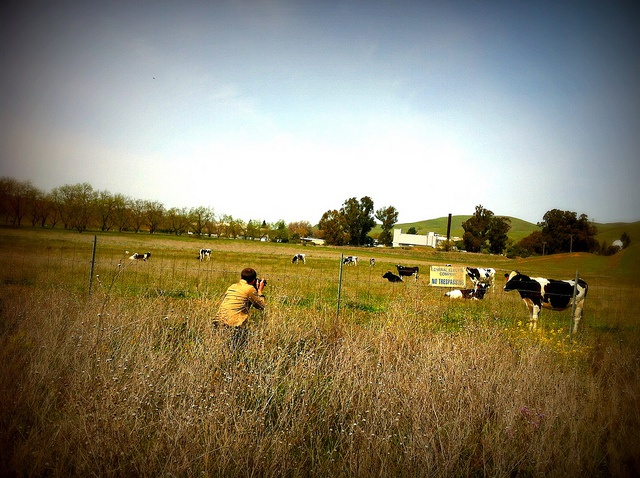Describe the objects in this image and their specific colors. I can see cow in black, olive, and tan tones, people in black, gold, olive, and orange tones, cow in black, ivory, olive, and khaki tones, cow in black, ivory, maroon, and olive tones, and cow in black, olive, gray, and khaki tones in this image. 